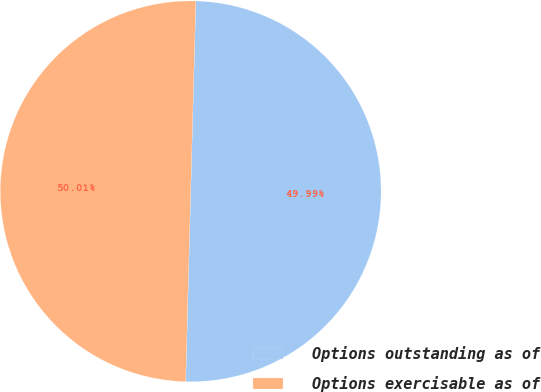Convert chart to OTSL. <chart><loc_0><loc_0><loc_500><loc_500><pie_chart><fcel>Options outstanding as of<fcel>Options exercisable as of<nl><fcel>49.99%<fcel>50.01%<nl></chart> 